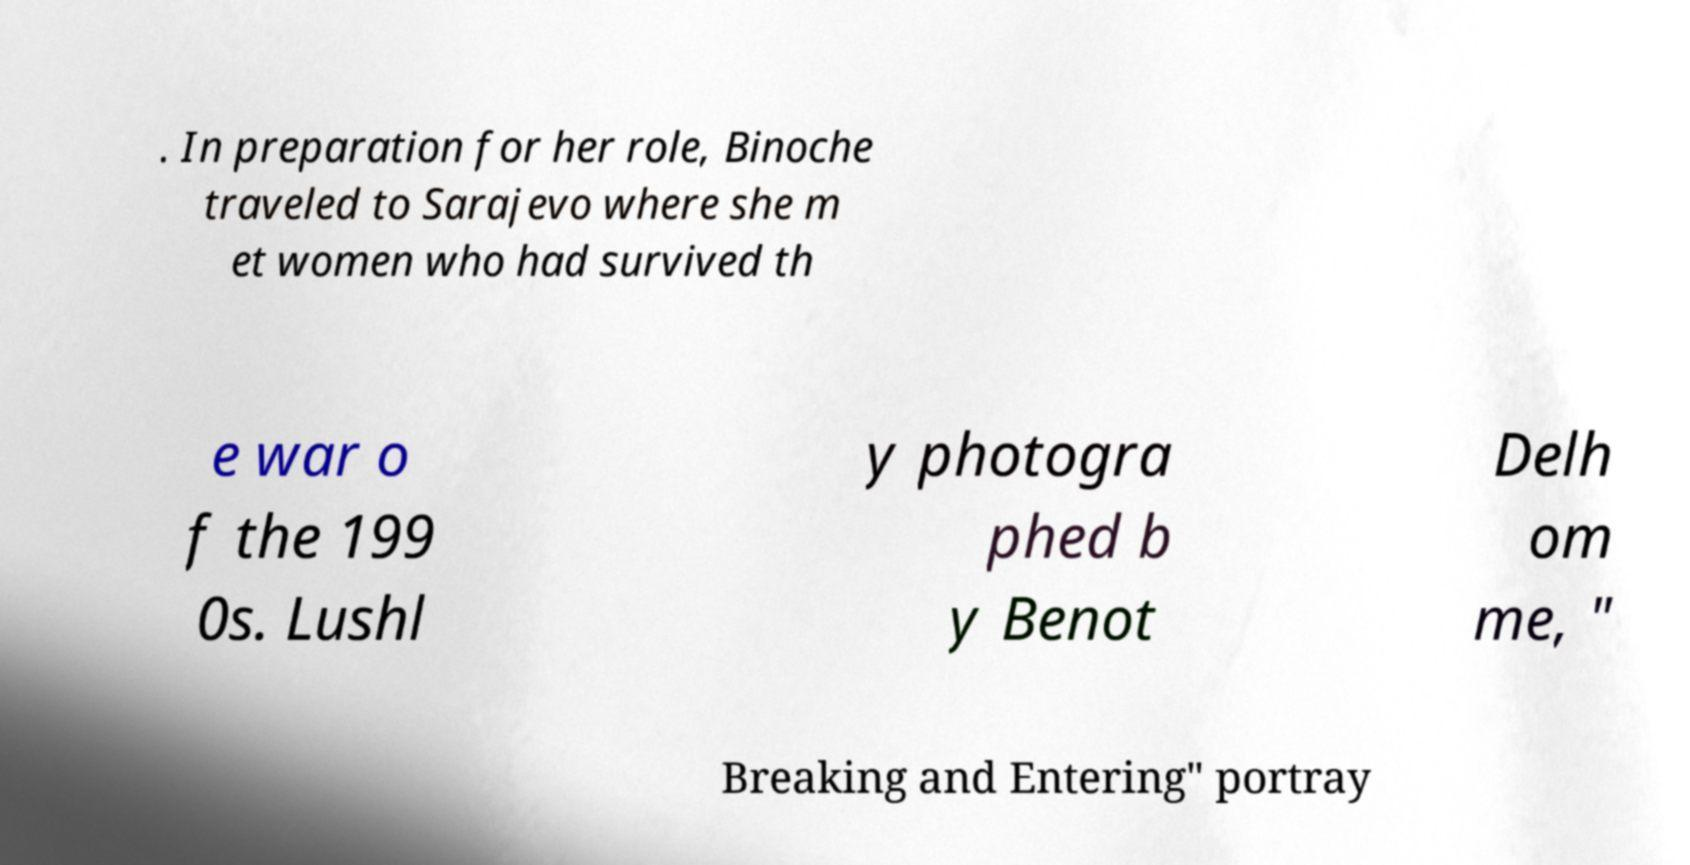Could you extract and type out the text from this image? . In preparation for her role, Binoche traveled to Sarajevo where she m et women who had survived th e war o f the 199 0s. Lushl y photogra phed b y Benot Delh om me, " Breaking and Entering" portray 